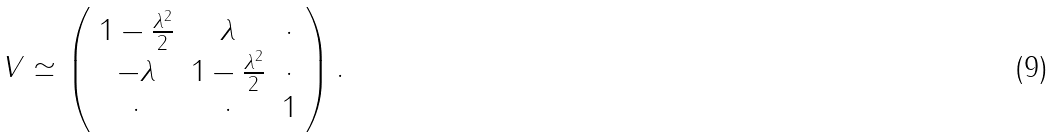<formula> <loc_0><loc_0><loc_500><loc_500>V \simeq \left ( \begin{array} { c c c } 1 - \frac { \lambda ^ { 2 } } { 2 } & \lambda & \cdot \\ - \lambda & 1 - \frac { \lambda ^ { 2 } } { 2 } & \cdot \\ \cdot & \cdot & 1 \end{array} \right ) .</formula> 